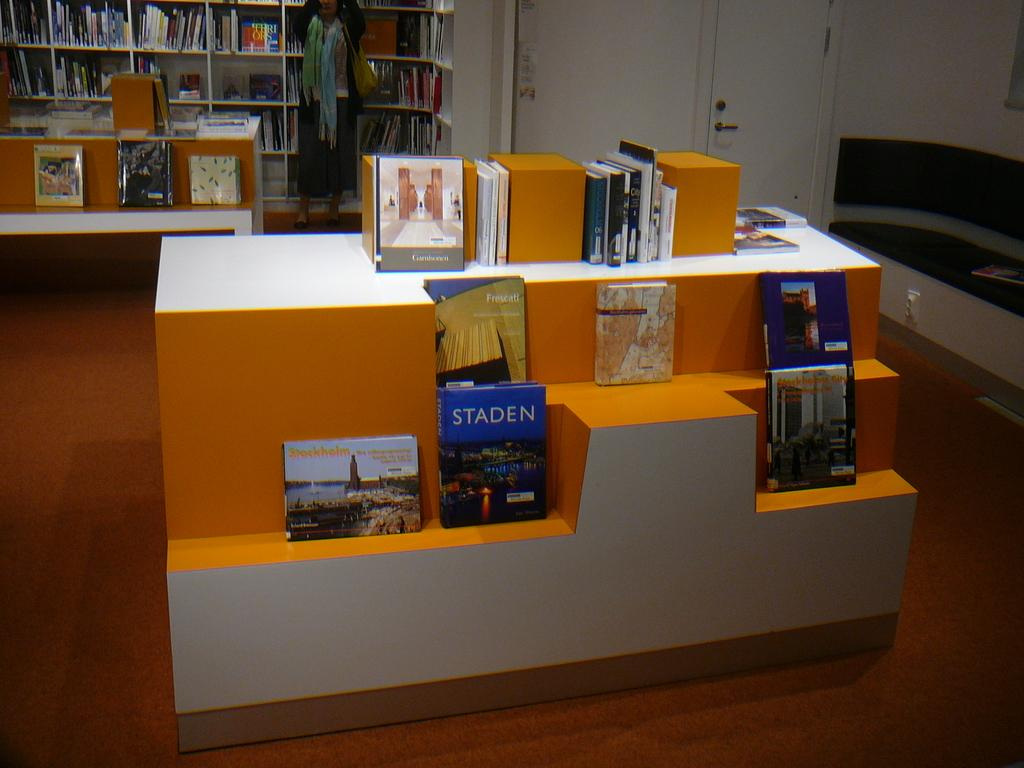What is on the stand in the image? There are books on a stand in the image. Can you describe the person in the background of the image? There is a person standing in the background of the image. What can be seen in the background of the image besides the person? There are books in racks, a wall, doors, and some objects visible in the background of the image. What type of oven is visible in the image? There is no oven present in the image. How many snakes are slithering on the books in the image? There are no snakes present in the image; it features books on a stand and in racks, along with a person and various background elements. 